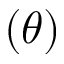<formula> <loc_0><loc_0><loc_500><loc_500>( \theta )</formula> 